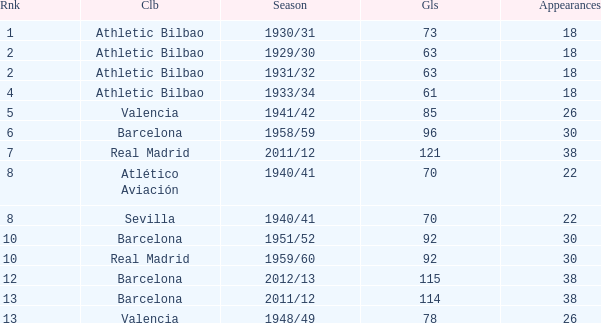How many apps when the rank was after 13 and having more than 73 goals? None. 